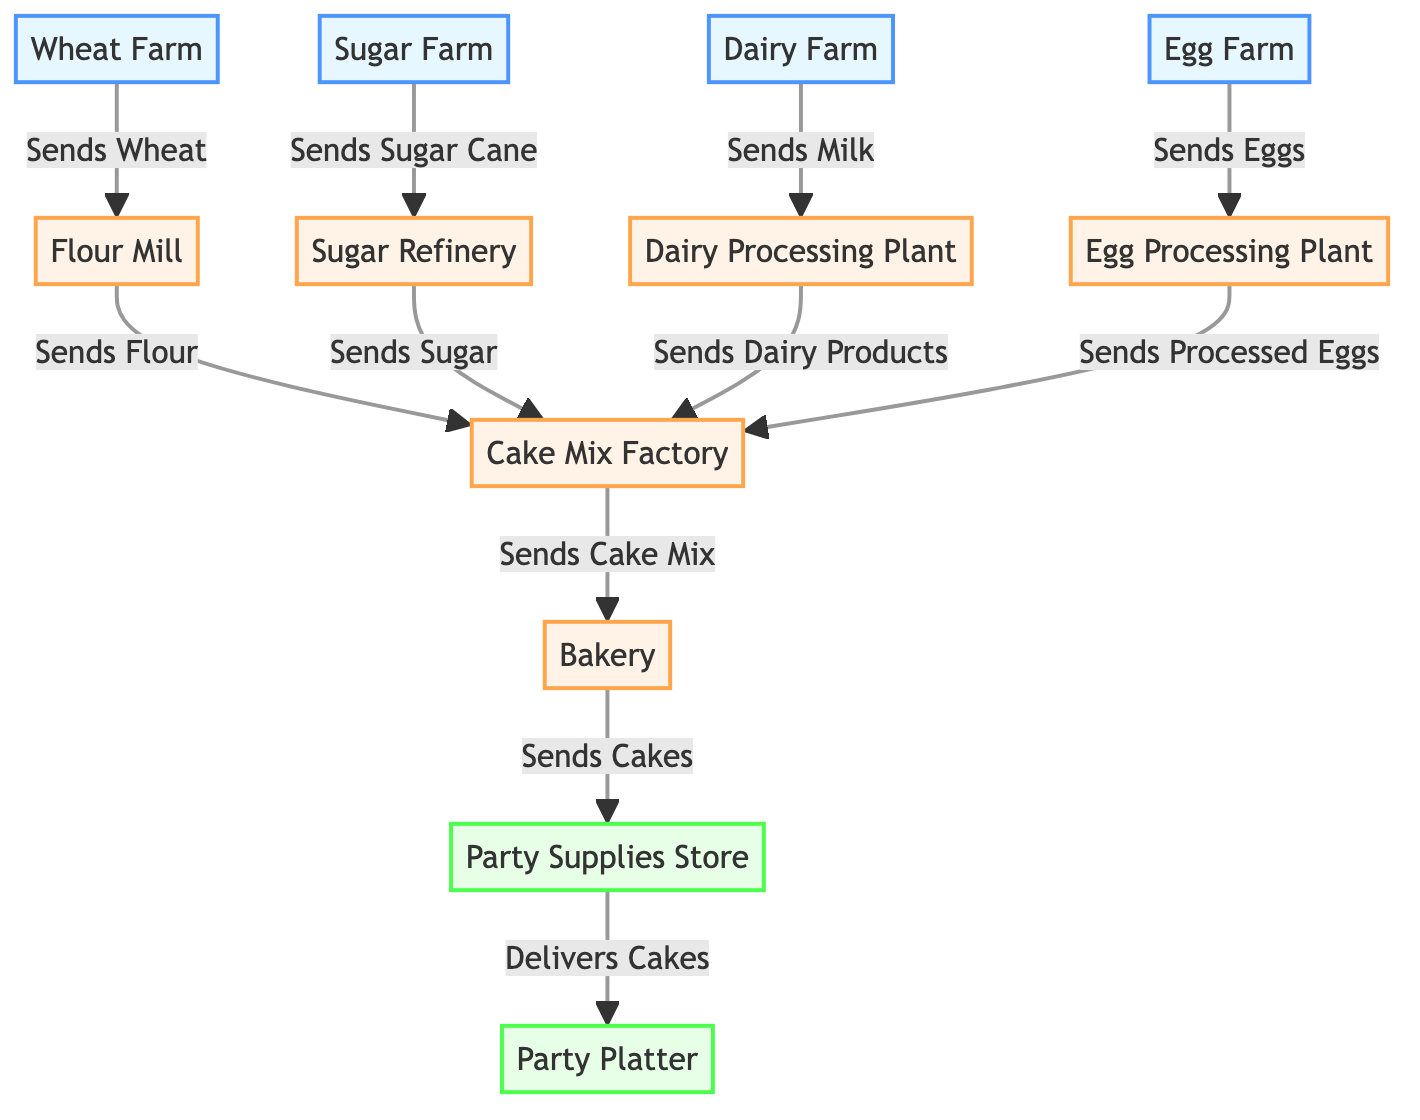What is the first step in the cake ingredients supply chain? The first node in the diagram is the Wheat Farm, which is where the supply chain starts as it sends Wheat to the Flour Mill.
Answer: Wheat Farm How many processing stages are there in the diagram? By counting the nodes categorized as processing, it includes the Flour Mill, Sugar Refinery, Dairy Processing Plant, Egg Processing Plant, Cake Mix Factory, and Bakery, totaling six processing stages.
Answer: 6 Which farm sends sugar cane to the refinery? The Sugar Farm is identified in the diagram as sending Sugar Cane to the Sugar Refinery, specifically marked in the flow from the farm to the processing stage.
Answer: Sugar Farm What is the final product sent to the party platter? The last item flowing from the Party Supplies Store to the Party Platter is Cakes, as indicated in the flow established in the diagram.
Answer: Cakes Which ingredient is processed and sent by the Dairy Processing Plant? The Dairy Processing Plant sends Dairy Products to the Cake Mix Factory, as shown in the diagram flow, depicting the processing stages.
Answer: Dairy Products How many farms are involved in the cake ingredients supply chain? The diagram displays four nodes classified as farms: Wheat Farm, Sugar Farm, Dairy Farm, and Egg Farm. Thus, there are four farms involved.
Answer: 4 What is the relationship between the Egg Farm and Cake Mix Factory? The Egg Farm sends Eggs to the Egg Processing Plant, which then sends Processed Eggs to the Cake Mix Factory, establishing a two-step relationship in the supply chain.
Answer: Sends Eggs Which node receives flour from the Flour Mill? The Cake Mix Factory is depicted in the diagram as receiving Flour from the Flour Mill, showing the flow of ingredients in the supply chain.
Answer: Cake Mix Factory What role does the Party Supplies Store play in the supply chain? The Party Supplies Store acts as a retail outlet receiving finished Cakes from the Bakery, prior to delivering them to the Party Platter.
Answer: Retail outlet 